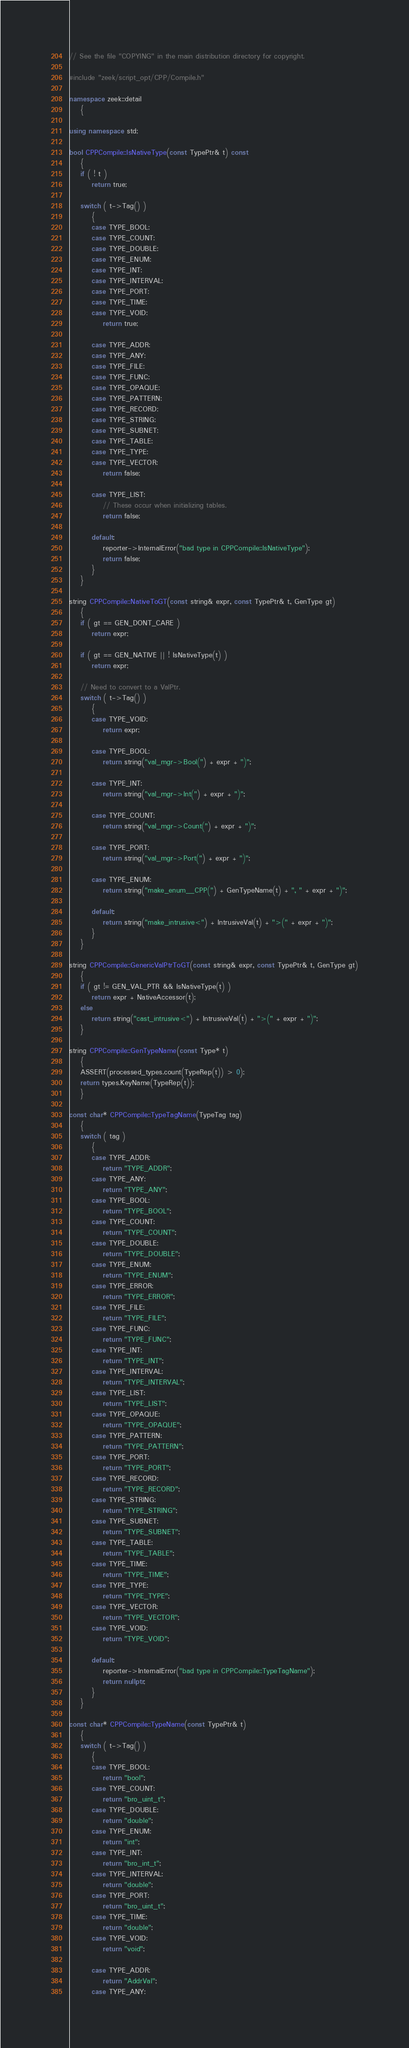Convert code to text. <code><loc_0><loc_0><loc_500><loc_500><_C++_>// See the file "COPYING" in the main distribution directory for copyright.

#include "zeek/script_opt/CPP/Compile.h"

namespace zeek::detail
	{

using namespace std;

bool CPPCompile::IsNativeType(const TypePtr& t) const
	{
	if ( ! t )
		return true;

	switch ( t->Tag() )
		{
		case TYPE_BOOL:
		case TYPE_COUNT:
		case TYPE_DOUBLE:
		case TYPE_ENUM:
		case TYPE_INT:
		case TYPE_INTERVAL:
		case TYPE_PORT:
		case TYPE_TIME:
		case TYPE_VOID:
			return true;

		case TYPE_ADDR:
		case TYPE_ANY:
		case TYPE_FILE:
		case TYPE_FUNC:
		case TYPE_OPAQUE:
		case TYPE_PATTERN:
		case TYPE_RECORD:
		case TYPE_STRING:
		case TYPE_SUBNET:
		case TYPE_TABLE:
		case TYPE_TYPE:
		case TYPE_VECTOR:
			return false;

		case TYPE_LIST:
			// These occur when initializing tables.
			return false;

		default:
			reporter->InternalError("bad type in CPPCompile::IsNativeType");
			return false;
		}
	}

string CPPCompile::NativeToGT(const string& expr, const TypePtr& t, GenType gt)
	{
	if ( gt == GEN_DONT_CARE )
		return expr;

	if ( gt == GEN_NATIVE || ! IsNativeType(t) )
		return expr;

	// Need to convert to a ValPtr.
	switch ( t->Tag() )
		{
		case TYPE_VOID:
			return expr;

		case TYPE_BOOL:
			return string("val_mgr->Bool(") + expr + ")";

		case TYPE_INT:
			return string("val_mgr->Int(") + expr + ")";

		case TYPE_COUNT:
			return string("val_mgr->Count(") + expr + ")";

		case TYPE_PORT:
			return string("val_mgr->Port(") + expr + ")";

		case TYPE_ENUM:
			return string("make_enum__CPP(") + GenTypeName(t) + ", " + expr + ")";

		default:
			return string("make_intrusive<") + IntrusiveVal(t) + ">(" + expr + ")";
		}
	}

string CPPCompile::GenericValPtrToGT(const string& expr, const TypePtr& t, GenType gt)
	{
	if ( gt != GEN_VAL_PTR && IsNativeType(t) )
		return expr + NativeAccessor(t);
	else
		return string("cast_intrusive<") + IntrusiveVal(t) + ">(" + expr + ")";
	}

string CPPCompile::GenTypeName(const Type* t)
	{
	ASSERT(processed_types.count(TypeRep(t)) > 0);
	return types.KeyName(TypeRep(t));
	}

const char* CPPCompile::TypeTagName(TypeTag tag)
	{
	switch ( tag )
		{
		case TYPE_ADDR:
			return "TYPE_ADDR";
		case TYPE_ANY:
			return "TYPE_ANY";
		case TYPE_BOOL:
			return "TYPE_BOOL";
		case TYPE_COUNT:
			return "TYPE_COUNT";
		case TYPE_DOUBLE:
			return "TYPE_DOUBLE";
		case TYPE_ENUM:
			return "TYPE_ENUM";
		case TYPE_ERROR:
			return "TYPE_ERROR";
		case TYPE_FILE:
			return "TYPE_FILE";
		case TYPE_FUNC:
			return "TYPE_FUNC";
		case TYPE_INT:
			return "TYPE_INT";
		case TYPE_INTERVAL:
			return "TYPE_INTERVAL";
		case TYPE_LIST:
			return "TYPE_LIST";
		case TYPE_OPAQUE:
			return "TYPE_OPAQUE";
		case TYPE_PATTERN:
			return "TYPE_PATTERN";
		case TYPE_PORT:
			return "TYPE_PORT";
		case TYPE_RECORD:
			return "TYPE_RECORD";
		case TYPE_STRING:
			return "TYPE_STRING";
		case TYPE_SUBNET:
			return "TYPE_SUBNET";
		case TYPE_TABLE:
			return "TYPE_TABLE";
		case TYPE_TIME:
			return "TYPE_TIME";
		case TYPE_TYPE:
			return "TYPE_TYPE";
		case TYPE_VECTOR:
			return "TYPE_VECTOR";
		case TYPE_VOID:
			return "TYPE_VOID";

		default:
			reporter->InternalError("bad type in CPPCompile::TypeTagName");
			return nullptr;
		}
	}

const char* CPPCompile::TypeName(const TypePtr& t)
	{
	switch ( t->Tag() )
		{
		case TYPE_BOOL:
			return "bool";
		case TYPE_COUNT:
			return "bro_uint_t";
		case TYPE_DOUBLE:
			return "double";
		case TYPE_ENUM:
			return "int";
		case TYPE_INT:
			return "bro_int_t";
		case TYPE_INTERVAL:
			return "double";
		case TYPE_PORT:
			return "bro_uint_t";
		case TYPE_TIME:
			return "double";
		case TYPE_VOID:
			return "void";

		case TYPE_ADDR:
			return "AddrVal";
		case TYPE_ANY:</code> 